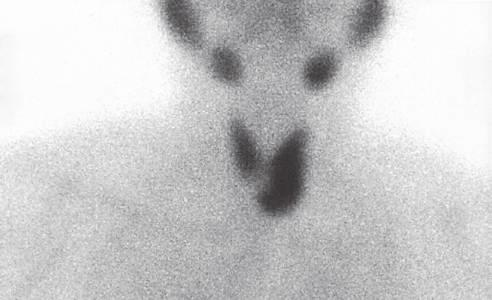what is useful in localizing and distinguishing adenomas from parathyroid hyperplasia, in which more than one gland will demonstrate increased uptake?
Answer the question using a single word or phrase. Preoperative scintigraphy 